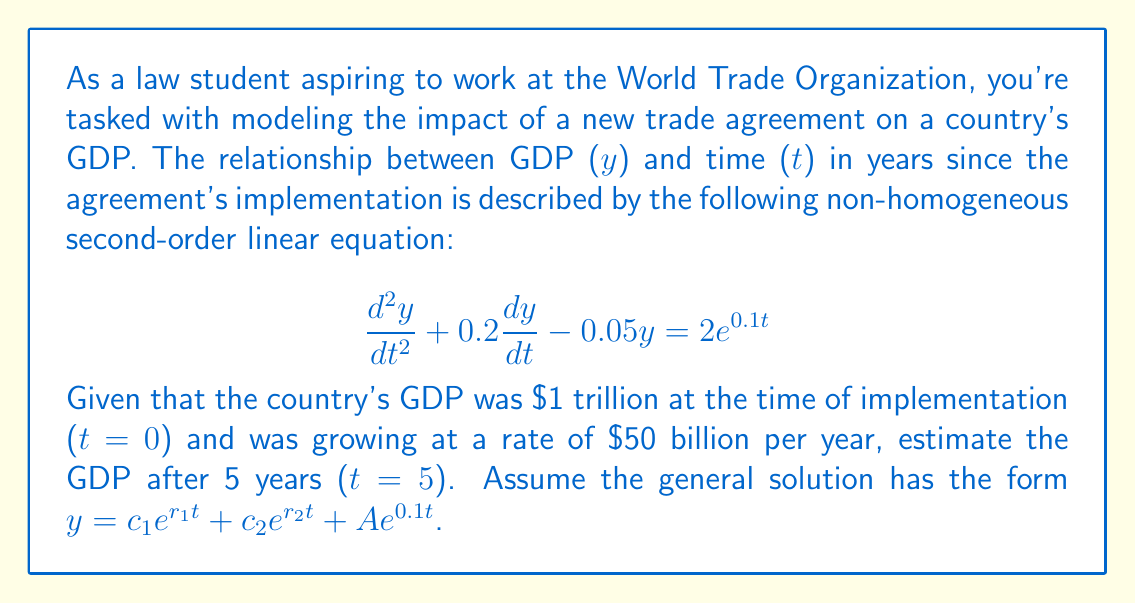Provide a solution to this math problem. Let's solve this problem step by step:

1) First, we need to find the complementary solution. The characteristic equation is:
   $$r^2 + 0.2r - 0.05 = 0$$

2) Solving this quadratic equation:
   $$r = \frac{-0.2 \pm \sqrt{0.2^2 + 4(0.05)}}{2} = \frac{-0.2 \pm \sqrt{0.24}}{2}$$
   $$r_1 = \frac{-0.2 + 0.49}{2} = 0.145$$
   $$r_2 = \frac{-0.2 - 0.49}{2} = -0.345$$

3) For the particular solution, we assume $y_p = Ae^{0.1t}$. Substituting this into the original equation:
   $$(0.1^2)Ae^{0.1t} + 0.2(0.1)Ae^{0.1t} - 0.05Ae^{0.1t} = 2e^{0.1t}$$
   $$0.01A + 0.02A - 0.05A = 2$$
   $$-0.02A = 2$$
   $$A = -100$$

4) The general solution is:
   $$y = c_1e^{0.145t} + c_2e^{-0.345t} - 100e^{0.1t}$$

5) Using the initial conditions:
   At t = 0: $y(0) = 1000$, so $c_1 + c_2 - 100 = 1000$
   At t = 0: $y'(0) = 50$, so $0.145c_1 - 0.345c_2 - 10 = 50$

6) Solving these equations:
   $c_1 = 1081.97$
   $c_2 = 18.03$

7) The final solution is:
   $$y = 1081.97e^{0.145t} + 18.03e^{-0.345t} - 100e^{0.1t}$$

8) To find GDP after 5 years, substitute t = 5:
   $$y(5) = 1081.97e^{0.145(5)} + 18.03e^{-0.345(5)} - 100e^{0.1(5)}$$
   $$= 1081.97(2.0567) + 18.03(0.1780) - 100(1.6487)$$
   $$= 2225.37 + 3.21 - 164.87$$
   $$= 2063.71$$
Answer: The estimated GDP after 5 years is approximately $2.064 trillion. 